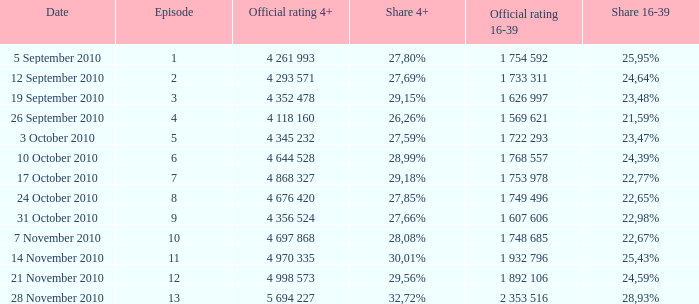For an episode with a 4+ share of 30.01%, what is its share in the 16-39 age group? 25,43%. 